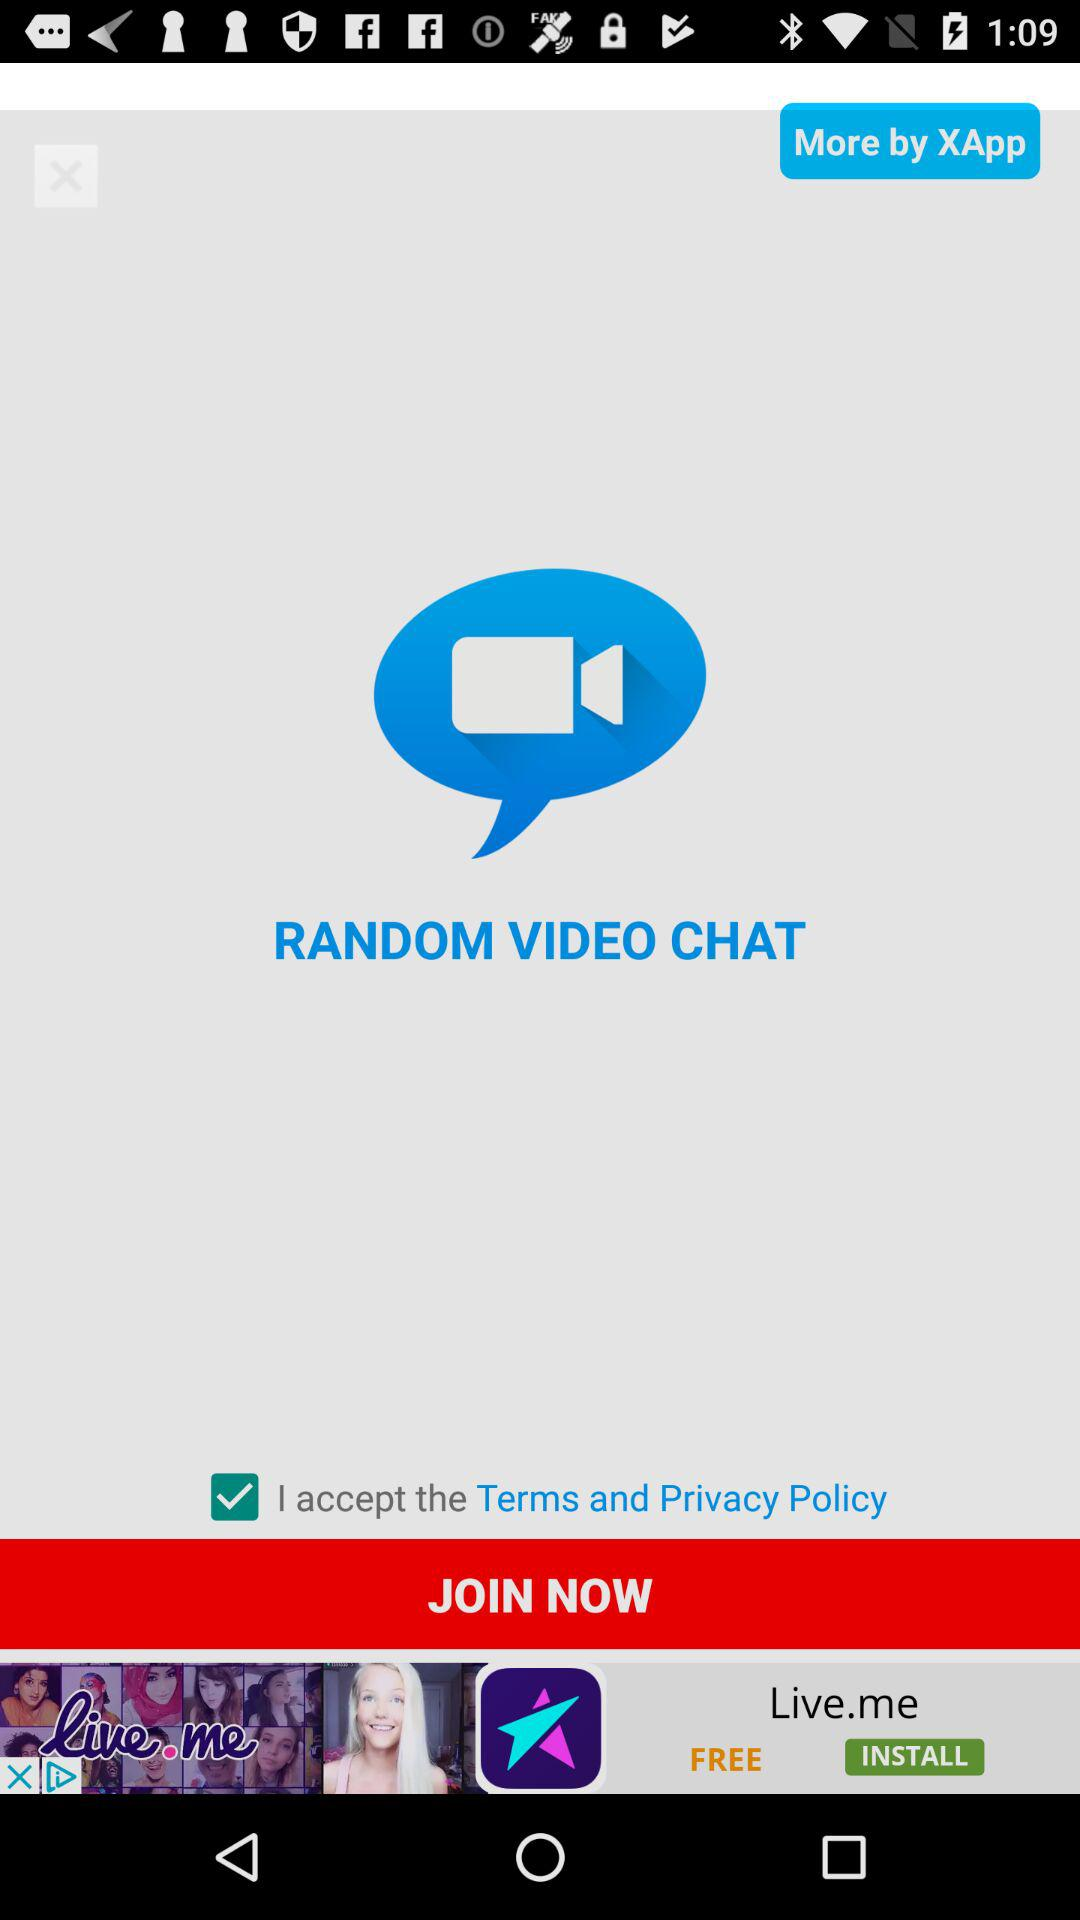What is the status of "I accept the Terms and Privacy Policy"? The status is "on". 